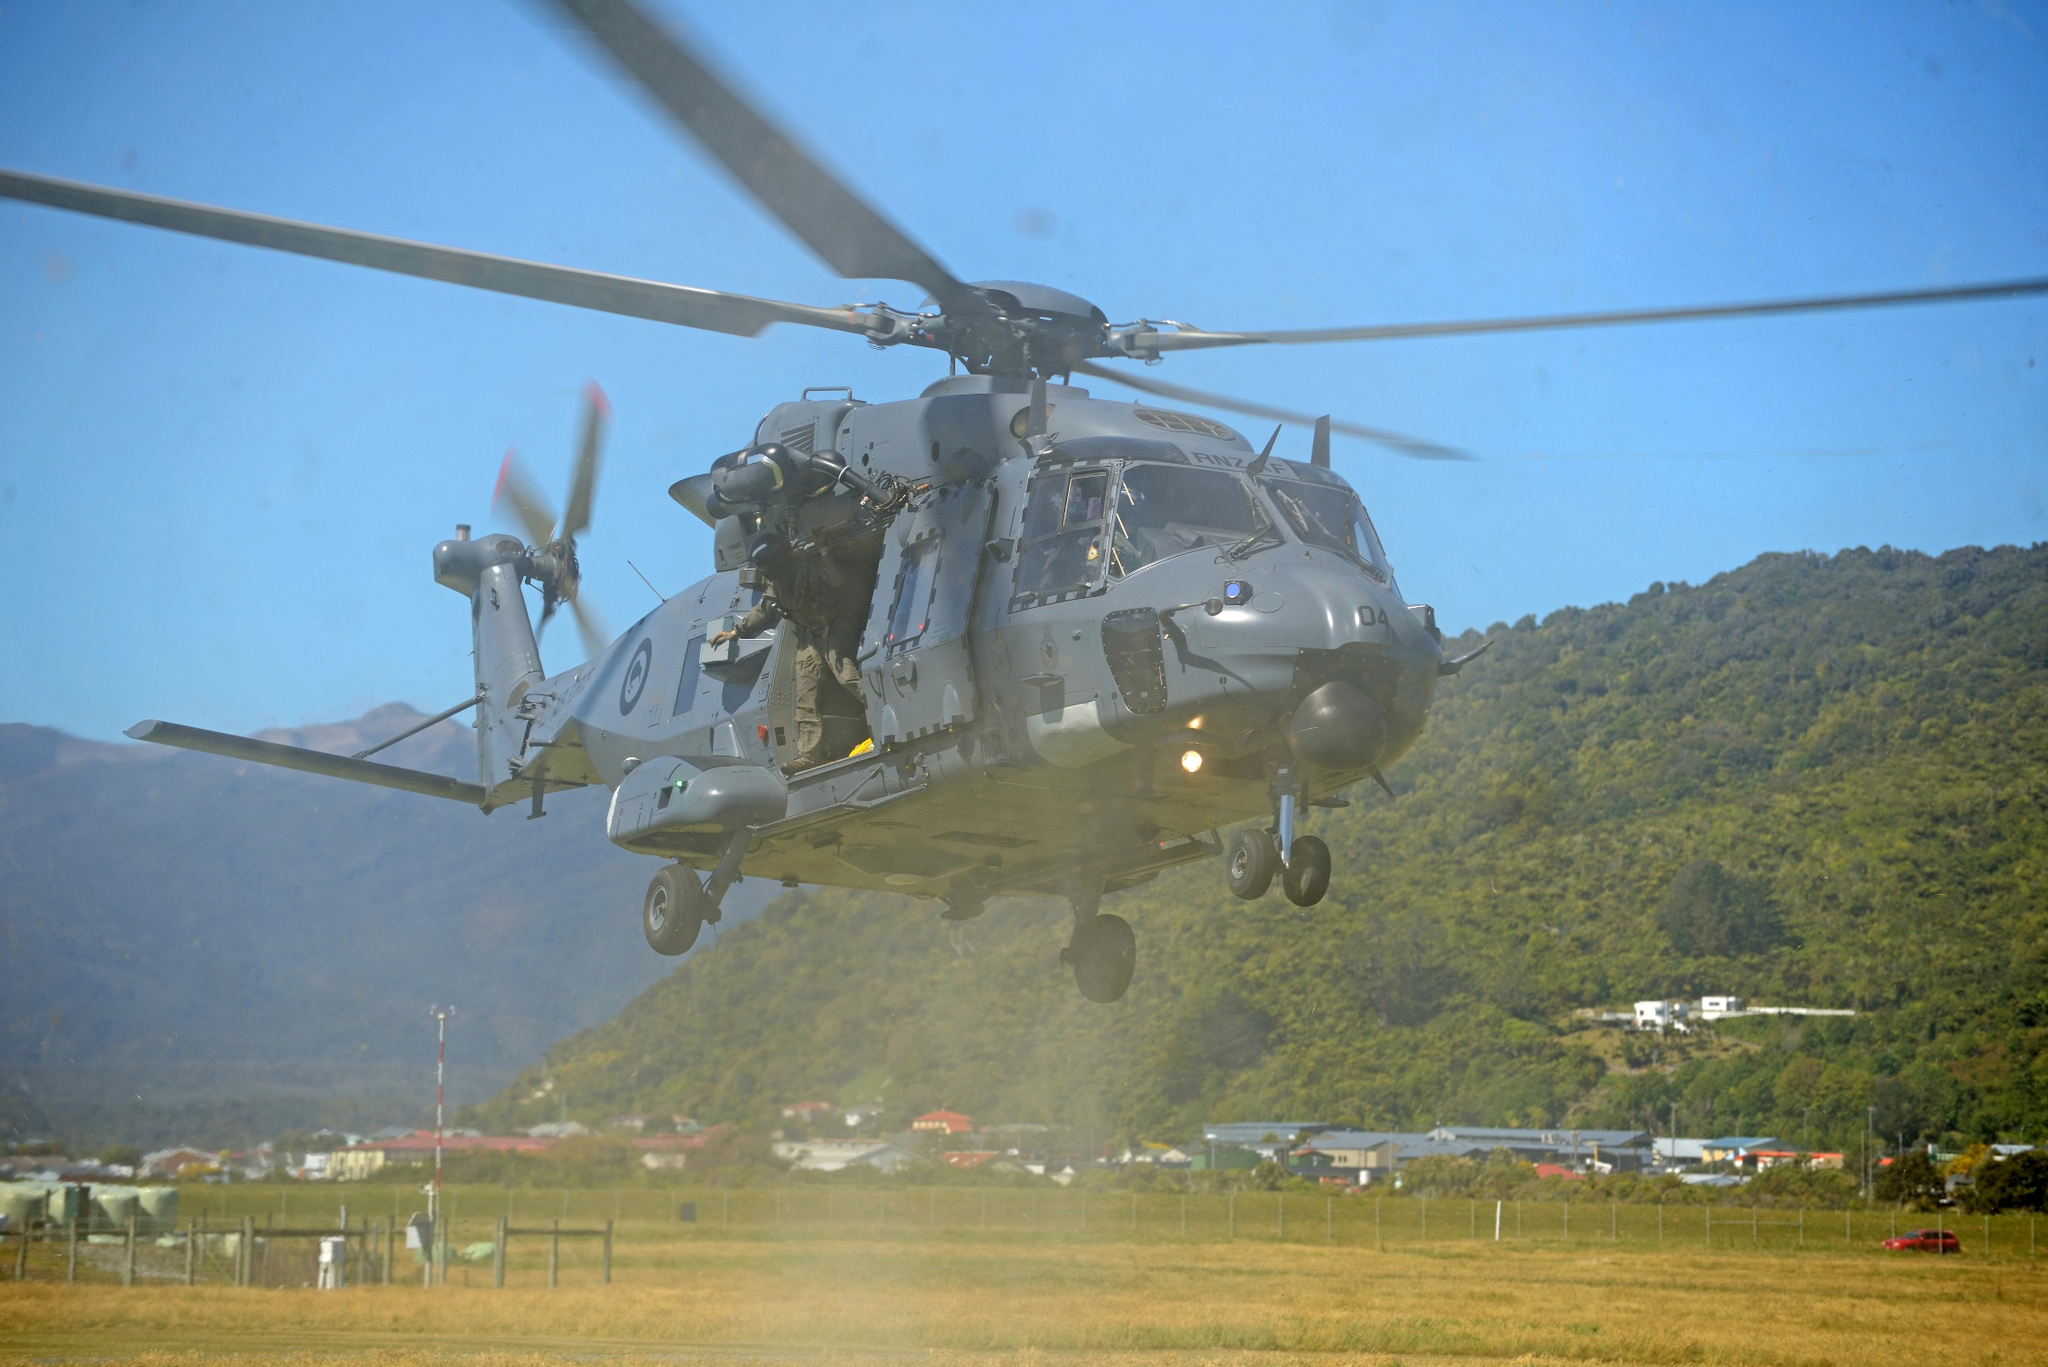Imagine this place in an apocalyptic scenario. In an apocalyptic scenario, the serene green field and distant mountains take on a more somber tone, with withered vegetation and a sky tinged with ominous hues. The once-untouched tranquility is now marred by the faint echoes of distant conflicts, as the helicopter, worn and battle-scarred, hovers vigilantly, constantly on the lookout for threats in this desolate landscape where survival and vigilance are the new norms. 